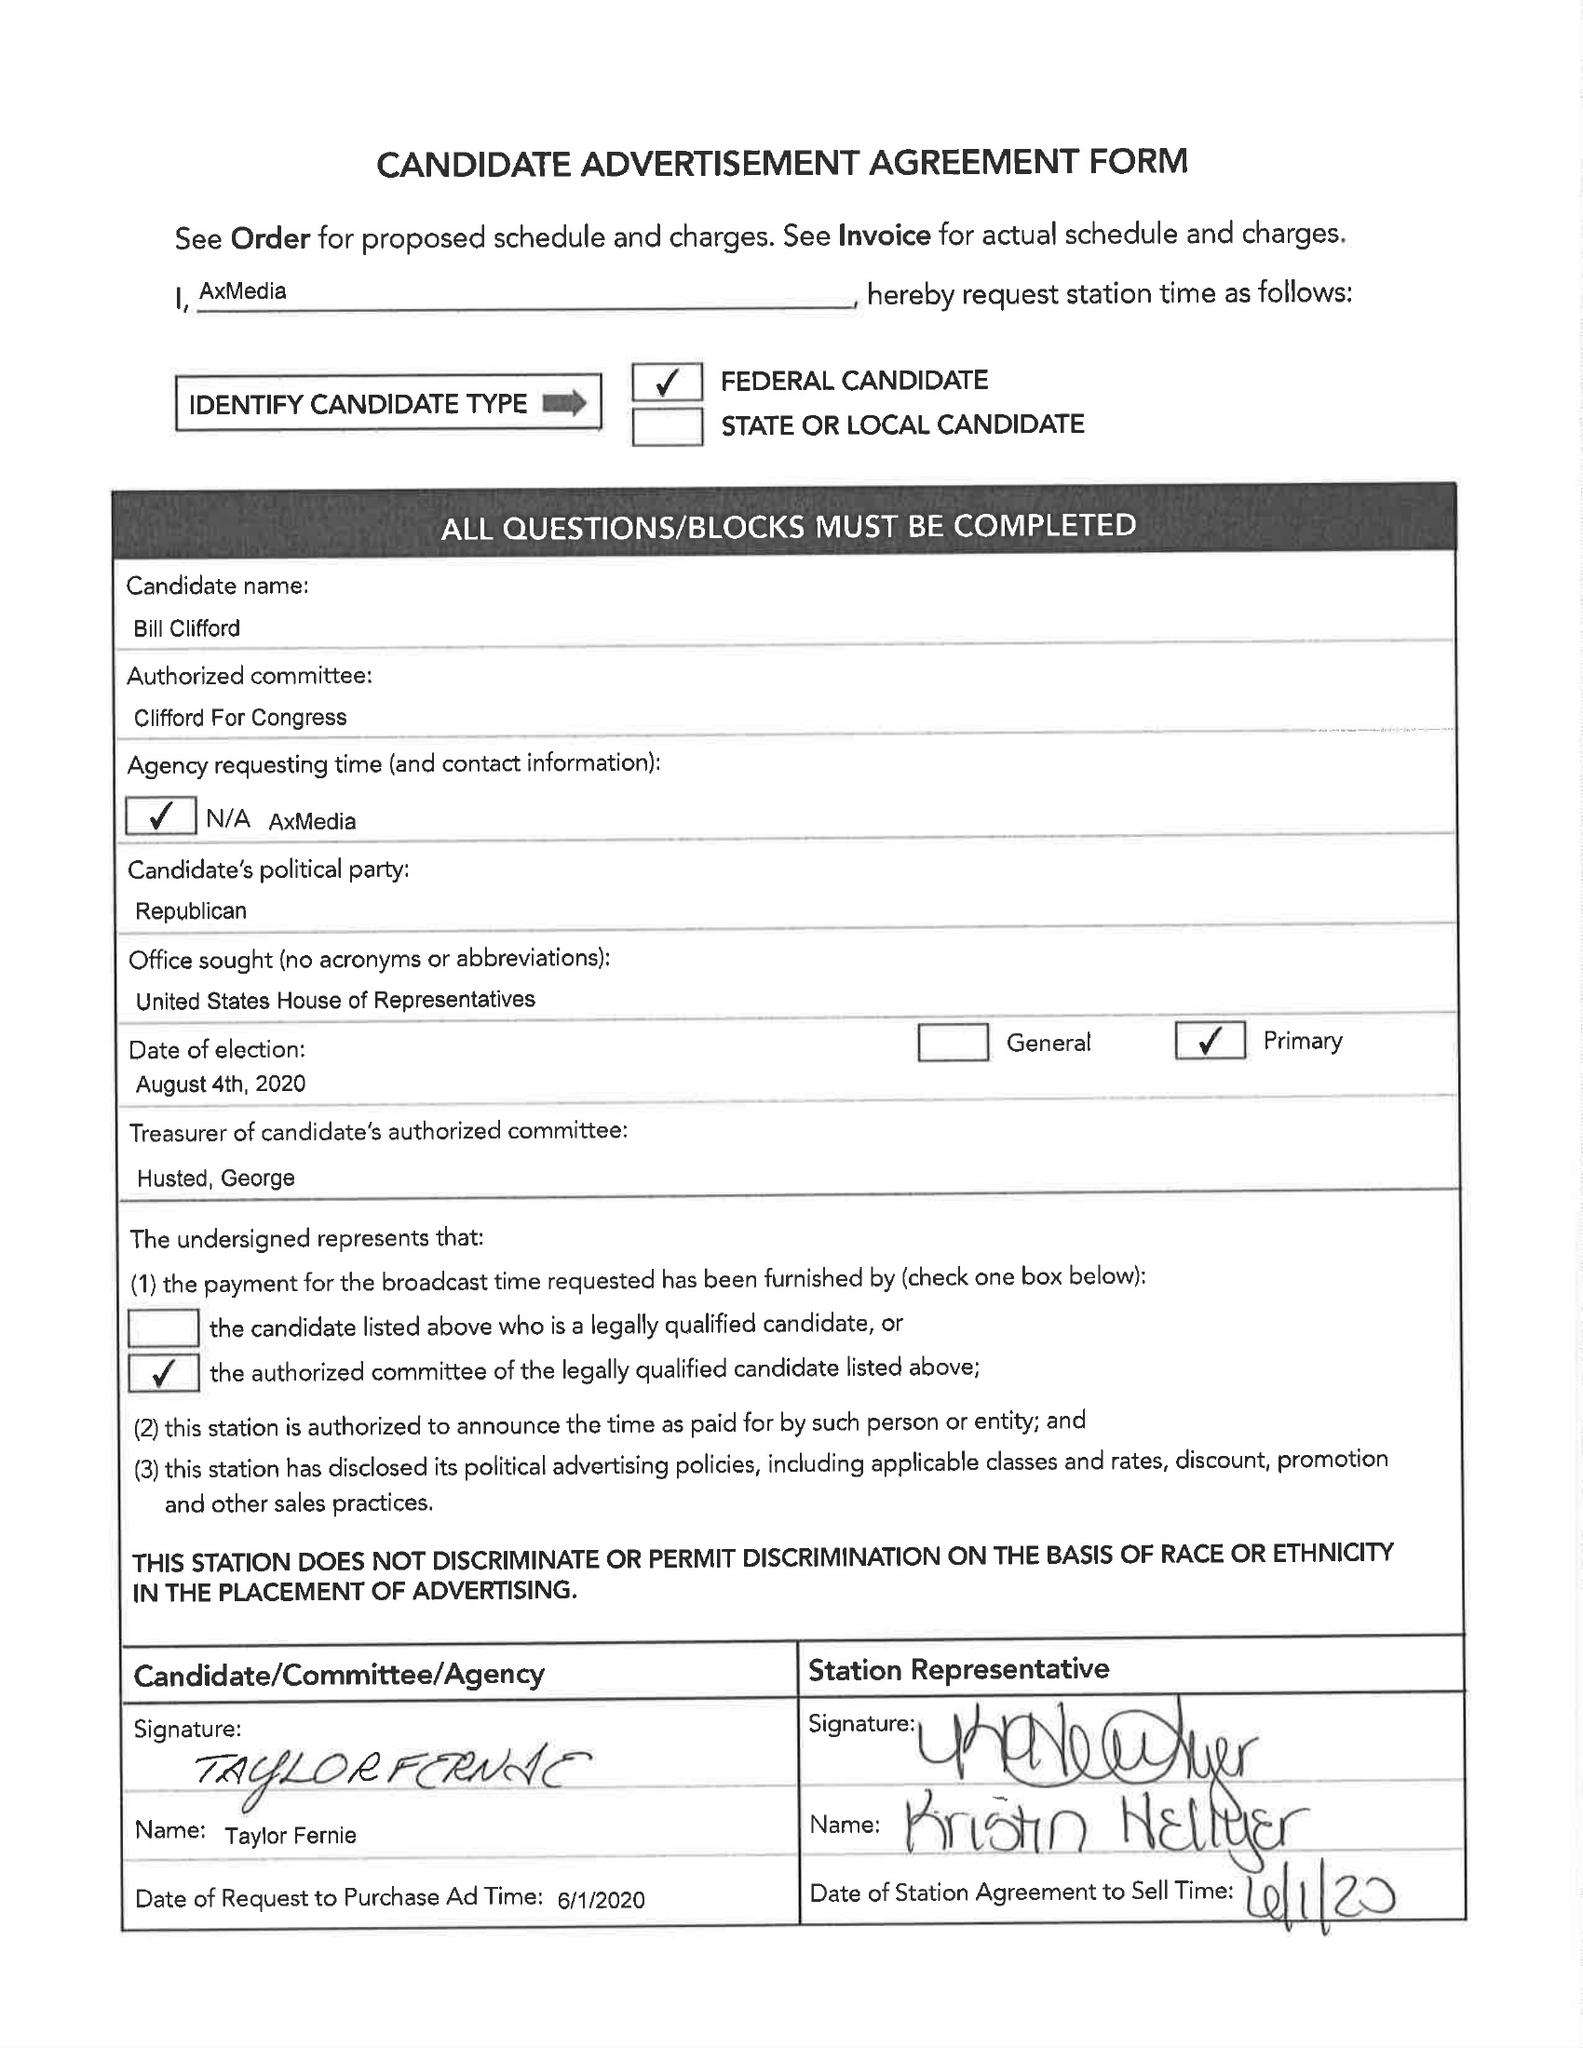What is the value for the gross_amount?
Answer the question using a single word or phrase. None 